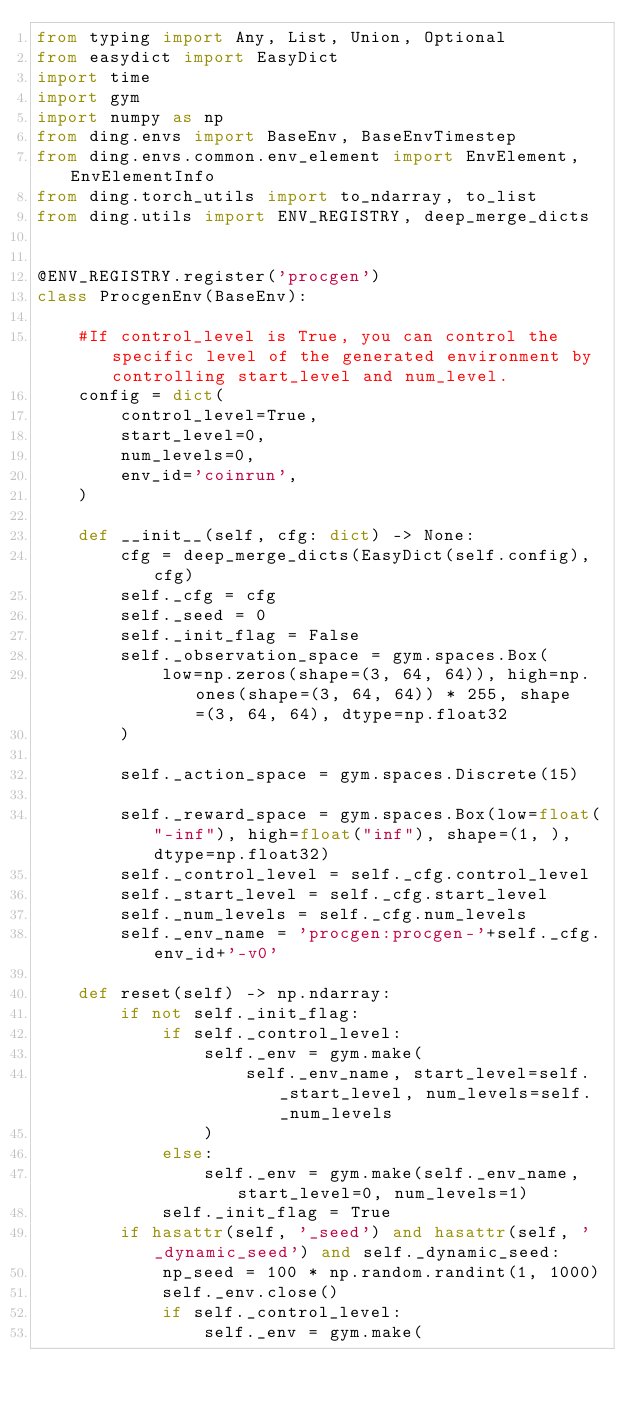Convert code to text. <code><loc_0><loc_0><loc_500><loc_500><_Python_>from typing import Any, List, Union, Optional
from easydict import EasyDict
import time
import gym
import numpy as np
from ding.envs import BaseEnv, BaseEnvTimestep
from ding.envs.common.env_element import EnvElement, EnvElementInfo
from ding.torch_utils import to_ndarray, to_list
from ding.utils import ENV_REGISTRY, deep_merge_dicts


@ENV_REGISTRY.register('procgen')
class ProcgenEnv(BaseEnv):

    #If control_level is True, you can control the specific level of the generated environment by controlling start_level and num_level.
    config = dict(
        control_level=True,
        start_level=0,
        num_levels=0,
        env_id='coinrun',
    )

    def __init__(self, cfg: dict) -> None:
        cfg = deep_merge_dicts(EasyDict(self.config), cfg)
        self._cfg = cfg
        self._seed = 0
        self._init_flag = False
        self._observation_space = gym.spaces.Box(
            low=np.zeros(shape=(3, 64, 64)), high=np.ones(shape=(3, 64, 64)) * 255, shape=(3, 64, 64), dtype=np.float32
        )

        self._action_space = gym.spaces.Discrete(15)

        self._reward_space = gym.spaces.Box(low=float("-inf"), high=float("inf"), shape=(1, ), dtype=np.float32)
        self._control_level = self._cfg.control_level
        self._start_level = self._cfg.start_level
        self._num_levels = self._cfg.num_levels
        self._env_name = 'procgen:procgen-'+self._cfg.env_id+'-v0'

    def reset(self) -> np.ndarray:
        if not self._init_flag:
            if self._control_level:
                self._env = gym.make(
                    self._env_name, start_level=self._start_level, num_levels=self._num_levels
                )
            else:
                self._env = gym.make(self._env_name, start_level=0, num_levels=1)
            self._init_flag = True
        if hasattr(self, '_seed') and hasattr(self, '_dynamic_seed') and self._dynamic_seed:
            np_seed = 100 * np.random.randint(1, 1000)
            self._env.close()
            if self._control_level:
                self._env = gym.make(</code> 